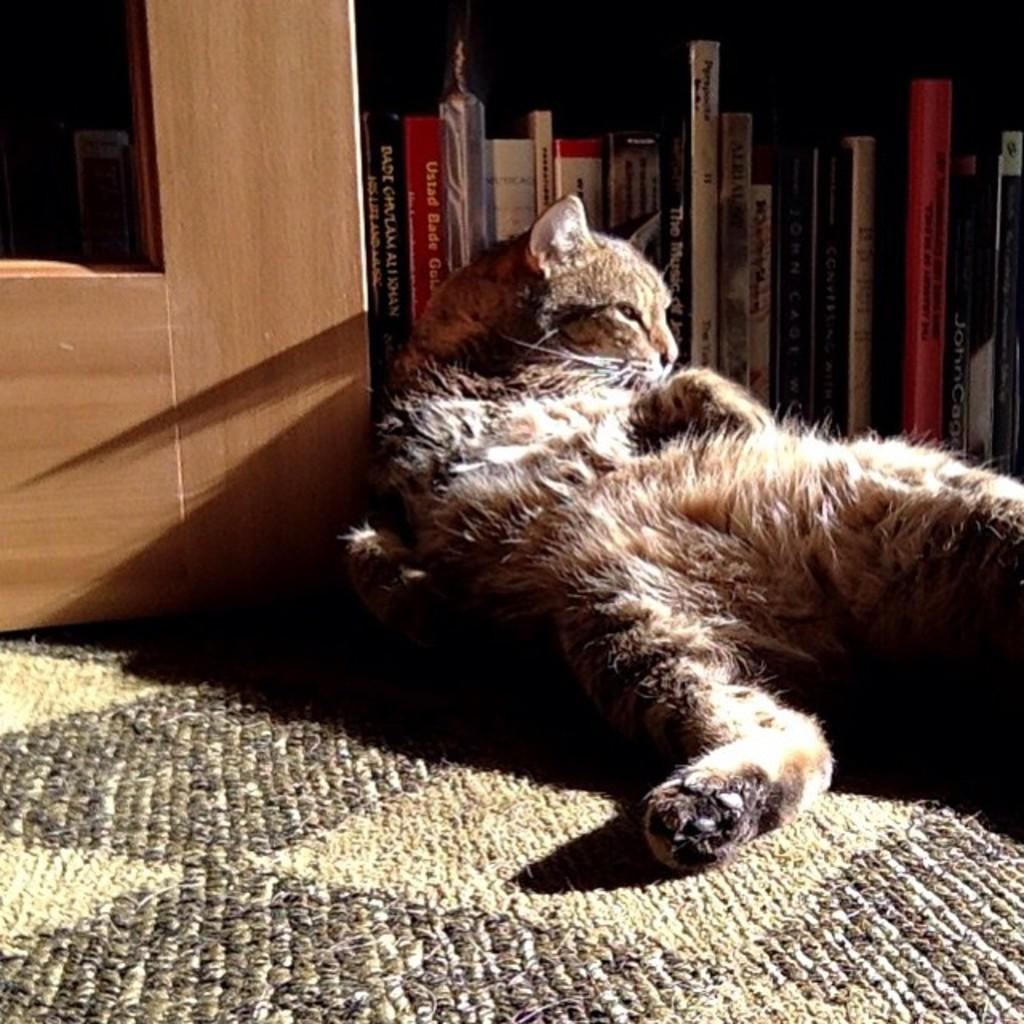What type of animal can be seen in the picture? There is a cat in the picture. What is the surface on which the cat is sitting? There is a carpet in the picture. What material is the wooden piece made of? The wooden piece in the picture is made of wood. How are the books arranged in the picture? The books are arranged in an order in the picture. What type of medical facility can be seen in the picture? There is no medical facility, such as a hospital, present in the picture. 